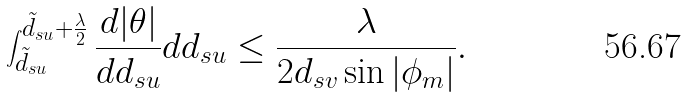Convert formula to latex. <formula><loc_0><loc_0><loc_500><loc_500>\int _ { \tilde { d } _ { s u } } ^ { \tilde { d } _ { s u } + \frac { \lambda } { 2 } } \frac { d | \theta | } { d d _ { s u } } d d _ { s u } & \leq \frac { \lambda } { 2 d _ { s v } \sin | \phi _ { m } | } .</formula> 